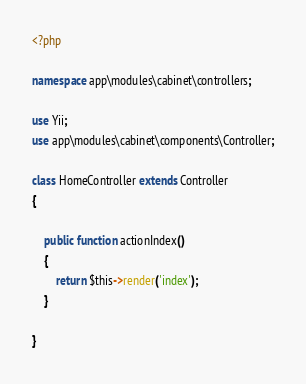<code> <loc_0><loc_0><loc_500><loc_500><_PHP_><?php

namespace app\modules\cabinet\controllers;

use Yii;
use app\modules\cabinet\components\Controller;

class HomeController extends Controller
{

    public function actionIndex()
    {
        return $this->render('index');
    }

}
</code> 